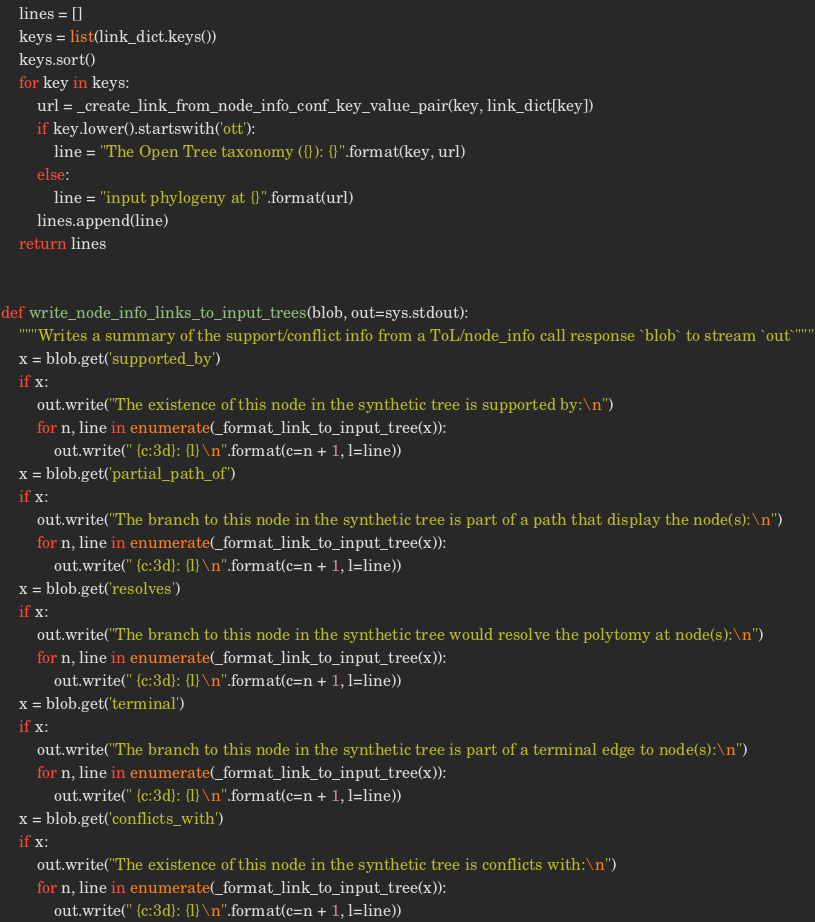<code> <loc_0><loc_0><loc_500><loc_500><_Python_>    lines = []
    keys = list(link_dict.keys())
    keys.sort()
    for key in keys:
        url = _create_link_from_node_info_conf_key_value_pair(key, link_dict[key])
        if key.lower().startswith('ott'):
            line = "The Open Tree taxonomy ({}): {}".format(key, url)
        else:
            line = "input phylogeny at {}".format(url)
        lines.append(line)
    return lines


def write_node_info_links_to_input_trees(blob, out=sys.stdout):
    """Writes a summary of the support/conflict info from a ToL/node_info call response `blob` to stream `out`"""
    x = blob.get('supported_by')
    if x:
        out.write("The existence of this node in the synthetic tree is supported by:\n")
        for n, line in enumerate(_format_link_to_input_tree(x)):
            out.write(" {c:3d}: {l}\n".format(c=n + 1, l=line))
    x = blob.get('partial_path_of')
    if x:
        out.write("The branch to this node in the synthetic tree is part of a path that display the node(s):\n")
        for n, line in enumerate(_format_link_to_input_tree(x)):
            out.write(" {c:3d}: {l}\n".format(c=n + 1, l=line))
    x = blob.get('resolves')
    if x:
        out.write("The branch to this node in the synthetic tree would resolve the polytomy at node(s):\n")
        for n, line in enumerate(_format_link_to_input_tree(x)):
            out.write(" {c:3d}: {l}\n".format(c=n + 1, l=line))
    x = blob.get('terminal')
    if x:
        out.write("The branch to this node in the synthetic tree is part of a terminal edge to node(s):\n")
        for n, line in enumerate(_format_link_to_input_tree(x)):
            out.write(" {c:3d}: {l}\n".format(c=n + 1, l=line))
    x = blob.get('conflicts_with')
    if x:
        out.write("The existence of this node in the synthetic tree is conflicts with:\n")
        for n, line in enumerate(_format_link_to_input_tree(x)):
            out.write(" {c:3d}: {l}\n".format(c=n + 1, l=line))

</code> 